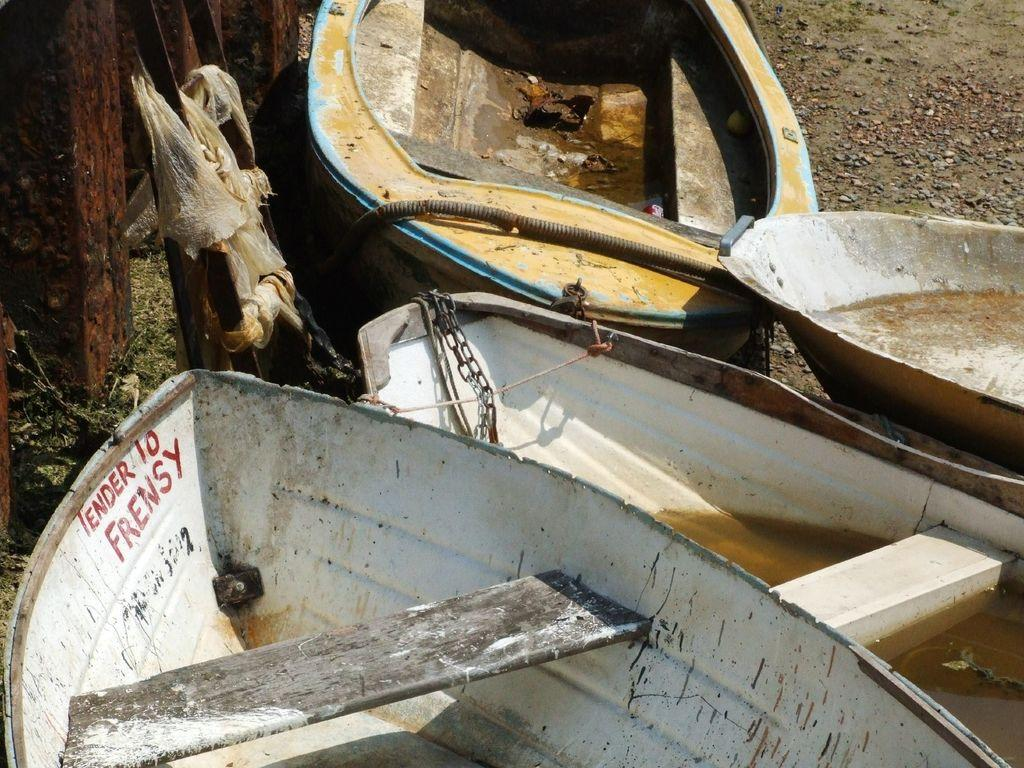What type of vehicles are in the image? There are boats in the image. Where are the boats located in the image? The boats are on the ground in the image. What type of music is being played on the boats in the image? There is no indication of music being played in the image; it only shows boats on the ground. 